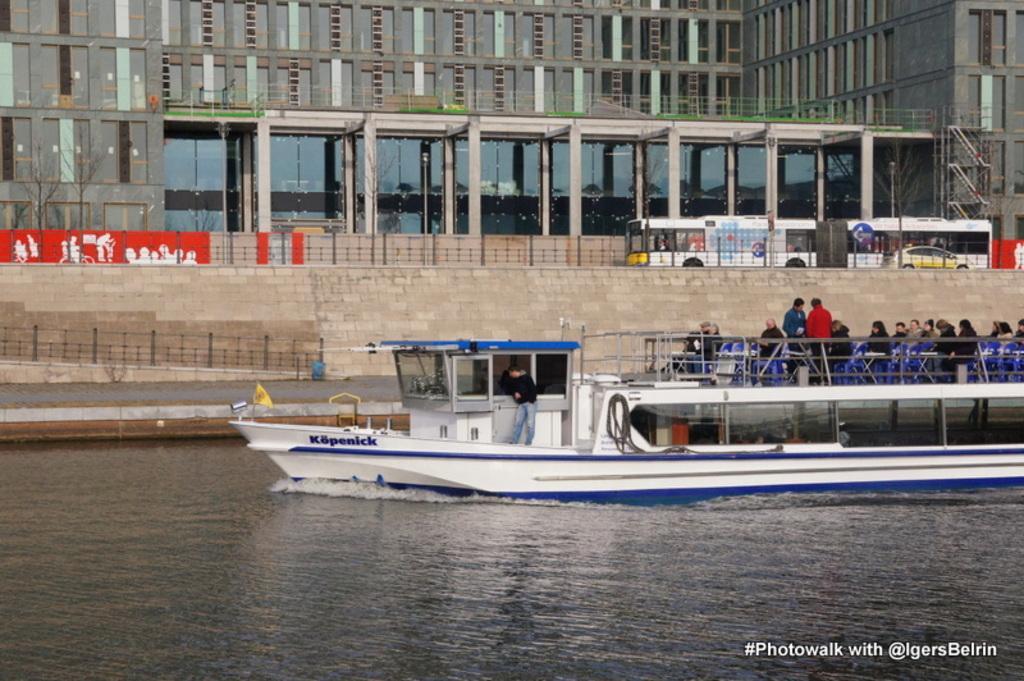Can you describe this image briefly? In the center of the image we can see a boat on the water. On the boat, we can see a few people are sitting, few people are standing and a few other objects. On the right side of the image, we can see some text. In the background, we can see buildings, vehicles and some objects. 